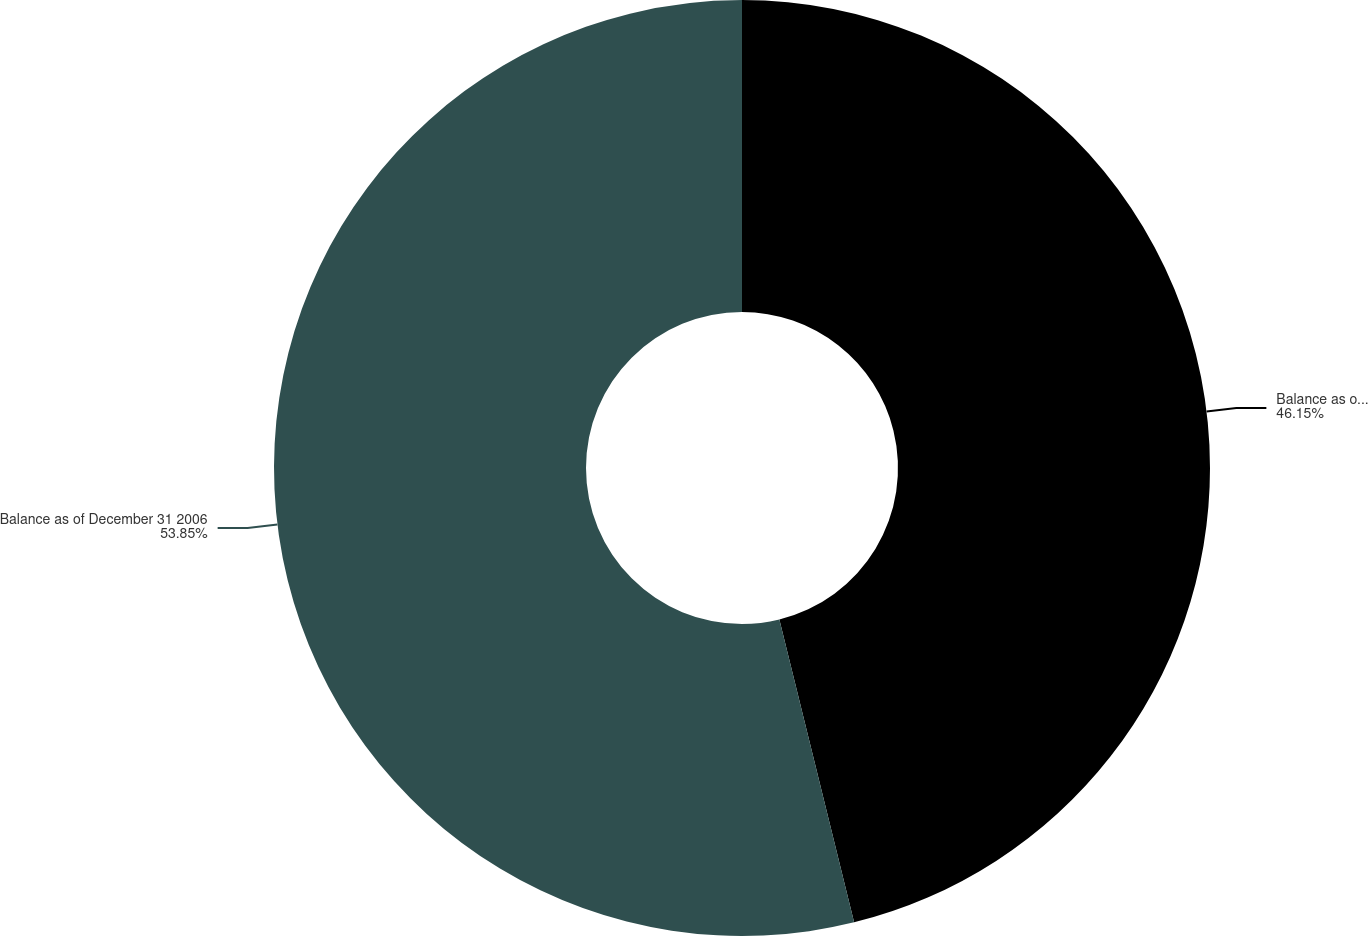Convert chart. <chart><loc_0><loc_0><loc_500><loc_500><pie_chart><fcel>Balance as of December 25 2005<fcel>Balance as of December 31 2006<nl><fcel>46.15%<fcel>53.85%<nl></chart> 